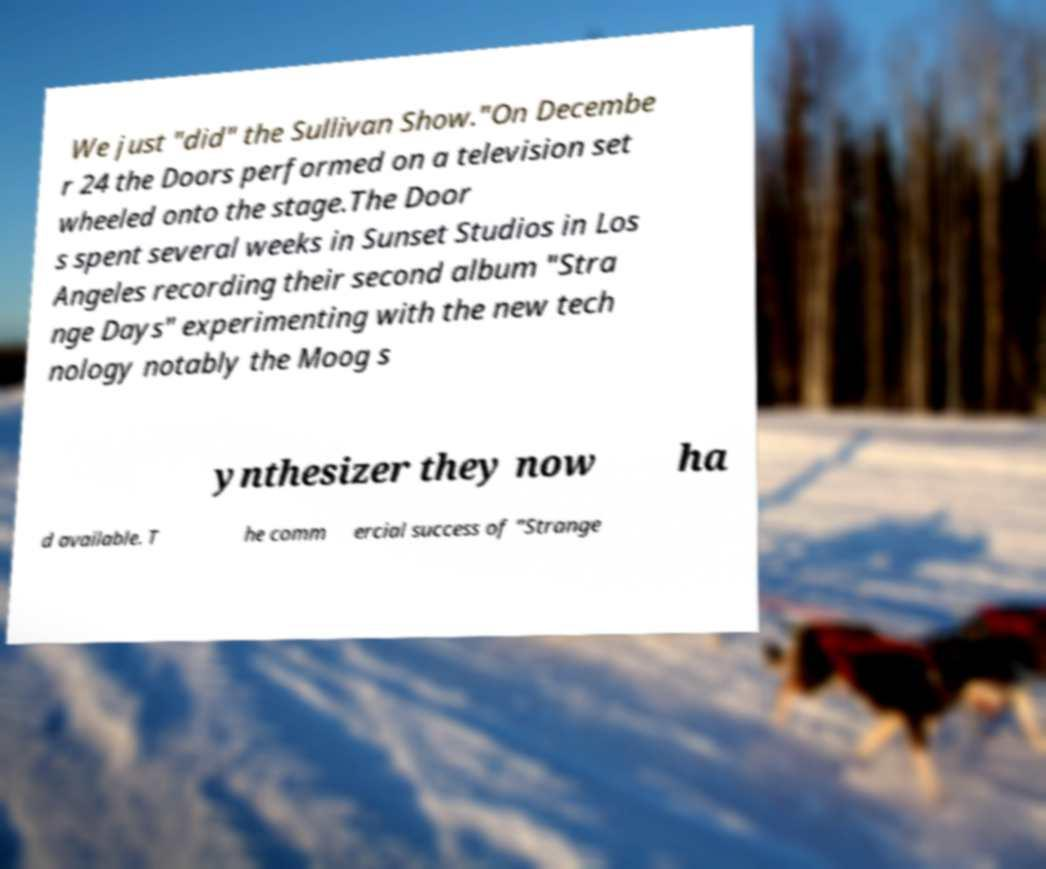For documentation purposes, I need the text within this image transcribed. Could you provide that? We just "did" the Sullivan Show."On Decembe r 24 the Doors performed on a television set wheeled onto the stage.The Door s spent several weeks in Sunset Studios in Los Angeles recording their second album "Stra nge Days" experimenting with the new tech nology notably the Moog s ynthesizer they now ha d available. T he comm ercial success of "Strange 